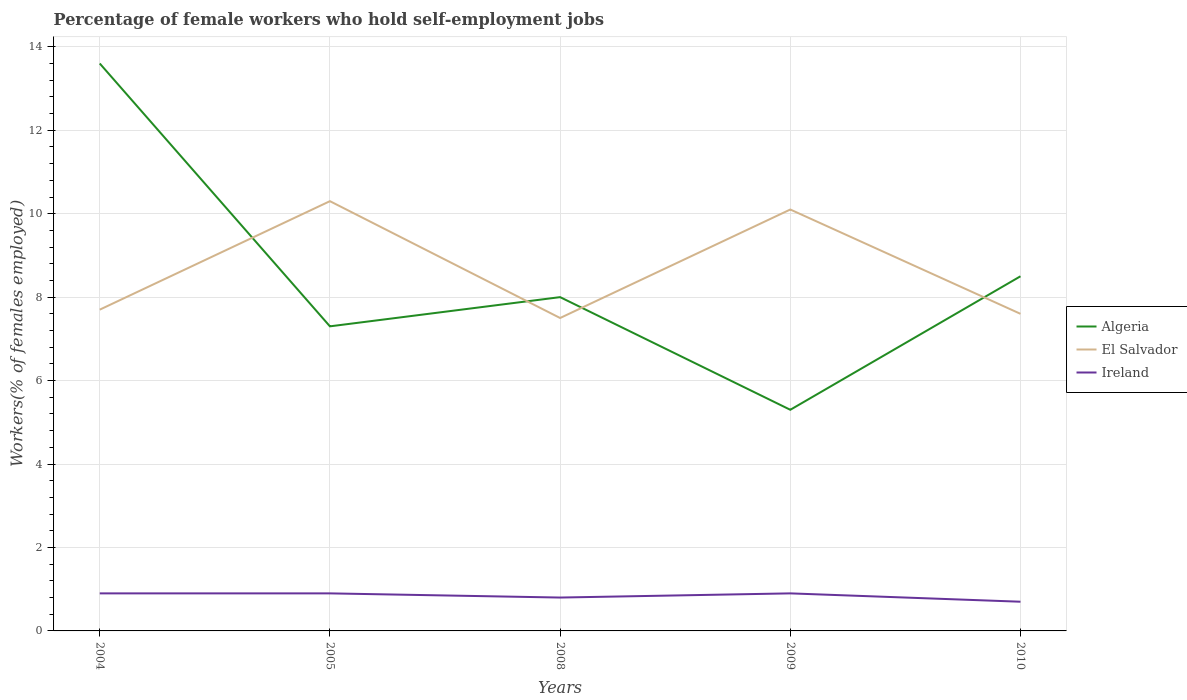Does the line corresponding to Ireland intersect with the line corresponding to Algeria?
Your answer should be very brief. No. Is the number of lines equal to the number of legend labels?
Give a very brief answer. Yes. Across all years, what is the maximum percentage of self-employed female workers in Ireland?
Offer a terse response. 0.7. In which year was the percentage of self-employed female workers in El Salvador maximum?
Offer a very short reply. 2008. What is the total percentage of self-employed female workers in Ireland in the graph?
Offer a terse response. 0.1. What is the difference between the highest and the second highest percentage of self-employed female workers in El Salvador?
Offer a very short reply. 2.8. Is the percentage of self-employed female workers in Ireland strictly greater than the percentage of self-employed female workers in El Salvador over the years?
Ensure brevity in your answer.  Yes. How many lines are there?
Make the answer very short. 3. Are the values on the major ticks of Y-axis written in scientific E-notation?
Keep it short and to the point. No. Does the graph contain any zero values?
Your response must be concise. No. Does the graph contain grids?
Your response must be concise. Yes. What is the title of the graph?
Ensure brevity in your answer.  Percentage of female workers who hold self-employment jobs. What is the label or title of the Y-axis?
Your answer should be compact. Workers(% of females employed). What is the Workers(% of females employed) in Algeria in 2004?
Give a very brief answer. 13.6. What is the Workers(% of females employed) in El Salvador in 2004?
Give a very brief answer. 7.7. What is the Workers(% of females employed) of Ireland in 2004?
Your answer should be compact. 0.9. What is the Workers(% of females employed) of Algeria in 2005?
Your response must be concise. 7.3. What is the Workers(% of females employed) in El Salvador in 2005?
Keep it short and to the point. 10.3. What is the Workers(% of females employed) of Ireland in 2005?
Provide a short and direct response. 0.9. What is the Workers(% of females employed) in Algeria in 2008?
Ensure brevity in your answer.  8. What is the Workers(% of females employed) in El Salvador in 2008?
Your response must be concise. 7.5. What is the Workers(% of females employed) of Ireland in 2008?
Provide a short and direct response. 0.8. What is the Workers(% of females employed) in Algeria in 2009?
Provide a short and direct response. 5.3. What is the Workers(% of females employed) in El Salvador in 2009?
Offer a terse response. 10.1. What is the Workers(% of females employed) in Ireland in 2009?
Your answer should be compact. 0.9. What is the Workers(% of females employed) of El Salvador in 2010?
Ensure brevity in your answer.  7.6. What is the Workers(% of females employed) of Ireland in 2010?
Provide a short and direct response. 0.7. Across all years, what is the maximum Workers(% of females employed) of Algeria?
Give a very brief answer. 13.6. Across all years, what is the maximum Workers(% of females employed) in El Salvador?
Provide a short and direct response. 10.3. Across all years, what is the maximum Workers(% of females employed) of Ireland?
Make the answer very short. 0.9. Across all years, what is the minimum Workers(% of females employed) in Algeria?
Give a very brief answer. 5.3. Across all years, what is the minimum Workers(% of females employed) of Ireland?
Give a very brief answer. 0.7. What is the total Workers(% of females employed) of Algeria in the graph?
Your answer should be compact. 42.7. What is the total Workers(% of females employed) in El Salvador in the graph?
Make the answer very short. 43.2. What is the difference between the Workers(% of females employed) of Algeria in 2004 and that in 2005?
Your response must be concise. 6.3. What is the difference between the Workers(% of females employed) of Ireland in 2004 and that in 2005?
Provide a succinct answer. 0. What is the difference between the Workers(% of females employed) of El Salvador in 2004 and that in 2008?
Your answer should be compact. 0.2. What is the difference between the Workers(% of females employed) in Ireland in 2004 and that in 2008?
Make the answer very short. 0.1. What is the difference between the Workers(% of females employed) in El Salvador in 2004 and that in 2009?
Give a very brief answer. -2.4. What is the difference between the Workers(% of females employed) of Algeria in 2004 and that in 2010?
Ensure brevity in your answer.  5.1. What is the difference between the Workers(% of females employed) of El Salvador in 2005 and that in 2008?
Provide a succinct answer. 2.8. What is the difference between the Workers(% of females employed) of Ireland in 2005 and that in 2008?
Your answer should be very brief. 0.1. What is the difference between the Workers(% of females employed) of El Salvador in 2005 and that in 2009?
Ensure brevity in your answer.  0.2. What is the difference between the Workers(% of females employed) in Algeria in 2005 and that in 2010?
Your response must be concise. -1.2. What is the difference between the Workers(% of females employed) of El Salvador in 2005 and that in 2010?
Offer a very short reply. 2.7. What is the difference between the Workers(% of females employed) of Ireland in 2005 and that in 2010?
Make the answer very short. 0.2. What is the difference between the Workers(% of females employed) in Algeria in 2008 and that in 2009?
Ensure brevity in your answer.  2.7. What is the difference between the Workers(% of females employed) of El Salvador in 2008 and that in 2009?
Provide a succinct answer. -2.6. What is the difference between the Workers(% of females employed) in Algeria in 2009 and that in 2010?
Offer a very short reply. -3.2. What is the difference between the Workers(% of females employed) of Ireland in 2009 and that in 2010?
Provide a succinct answer. 0.2. What is the difference between the Workers(% of females employed) in Algeria in 2004 and the Workers(% of females employed) in Ireland in 2005?
Your answer should be compact. 12.7. What is the difference between the Workers(% of females employed) of Algeria in 2004 and the Workers(% of females employed) of El Salvador in 2008?
Provide a succinct answer. 6.1. What is the difference between the Workers(% of females employed) of El Salvador in 2004 and the Workers(% of females employed) of Ireland in 2008?
Provide a short and direct response. 6.9. What is the difference between the Workers(% of females employed) of Algeria in 2004 and the Workers(% of females employed) of El Salvador in 2009?
Provide a succinct answer. 3.5. What is the difference between the Workers(% of females employed) of Algeria in 2004 and the Workers(% of females employed) of Ireland in 2009?
Offer a very short reply. 12.7. What is the difference between the Workers(% of females employed) in Algeria in 2004 and the Workers(% of females employed) in El Salvador in 2010?
Give a very brief answer. 6. What is the difference between the Workers(% of females employed) of El Salvador in 2004 and the Workers(% of females employed) of Ireland in 2010?
Your answer should be very brief. 7. What is the difference between the Workers(% of females employed) in Algeria in 2005 and the Workers(% of females employed) in El Salvador in 2009?
Give a very brief answer. -2.8. What is the difference between the Workers(% of females employed) in El Salvador in 2005 and the Workers(% of females employed) in Ireland in 2009?
Your response must be concise. 9.4. What is the difference between the Workers(% of females employed) in El Salvador in 2005 and the Workers(% of females employed) in Ireland in 2010?
Give a very brief answer. 9.6. What is the difference between the Workers(% of females employed) of Algeria in 2008 and the Workers(% of females employed) of El Salvador in 2009?
Keep it short and to the point. -2.1. What is the difference between the Workers(% of females employed) in Algeria in 2008 and the Workers(% of females employed) in Ireland in 2009?
Keep it short and to the point. 7.1. What is the difference between the Workers(% of females employed) of El Salvador in 2008 and the Workers(% of females employed) of Ireland in 2009?
Offer a very short reply. 6.6. What is the difference between the Workers(% of females employed) of Algeria in 2008 and the Workers(% of females employed) of El Salvador in 2010?
Ensure brevity in your answer.  0.4. What is the difference between the Workers(% of females employed) of Algeria in 2008 and the Workers(% of females employed) of Ireland in 2010?
Provide a short and direct response. 7.3. What is the average Workers(% of females employed) of Algeria per year?
Offer a very short reply. 8.54. What is the average Workers(% of females employed) of El Salvador per year?
Keep it short and to the point. 8.64. What is the average Workers(% of females employed) in Ireland per year?
Make the answer very short. 0.84. In the year 2004, what is the difference between the Workers(% of females employed) of Algeria and Workers(% of females employed) of Ireland?
Your answer should be compact. 12.7. In the year 2005, what is the difference between the Workers(% of females employed) in Algeria and Workers(% of females employed) in El Salvador?
Give a very brief answer. -3. In the year 2005, what is the difference between the Workers(% of females employed) in Algeria and Workers(% of females employed) in Ireland?
Your answer should be compact. 6.4. In the year 2005, what is the difference between the Workers(% of females employed) of El Salvador and Workers(% of females employed) of Ireland?
Give a very brief answer. 9.4. In the year 2008, what is the difference between the Workers(% of females employed) of Algeria and Workers(% of females employed) of El Salvador?
Offer a terse response. 0.5. In the year 2008, what is the difference between the Workers(% of females employed) of El Salvador and Workers(% of females employed) of Ireland?
Your answer should be very brief. 6.7. In the year 2009, what is the difference between the Workers(% of females employed) in Algeria and Workers(% of females employed) in El Salvador?
Your response must be concise. -4.8. In the year 2009, what is the difference between the Workers(% of females employed) of El Salvador and Workers(% of females employed) of Ireland?
Provide a short and direct response. 9.2. In the year 2010, what is the difference between the Workers(% of females employed) of Algeria and Workers(% of females employed) of El Salvador?
Your answer should be compact. 0.9. What is the ratio of the Workers(% of females employed) of Algeria in 2004 to that in 2005?
Your answer should be very brief. 1.86. What is the ratio of the Workers(% of females employed) in El Salvador in 2004 to that in 2005?
Ensure brevity in your answer.  0.75. What is the ratio of the Workers(% of females employed) in Algeria in 2004 to that in 2008?
Give a very brief answer. 1.7. What is the ratio of the Workers(% of females employed) of El Salvador in 2004 to that in 2008?
Your answer should be very brief. 1.03. What is the ratio of the Workers(% of females employed) of Algeria in 2004 to that in 2009?
Give a very brief answer. 2.57. What is the ratio of the Workers(% of females employed) in El Salvador in 2004 to that in 2009?
Provide a short and direct response. 0.76. What is the ratio of the Workers(% of females employed) of Algeria in 2004 to that in 2010?
Provide a succinct answer. 1.6. What is the ratio of the Workers(% of females employed) in El Salvador in 2004 to that in 2010?
Provide a succinct answer. 1.01. What is the ratio of the Workers(% of females employed) of Ireland in 2004 to that in 2010?
Keep it short and to the point. 1.29. What is the ratio of the Workers(% of females employed) of Algeria in 2005 to that in 2008?
Your answer should be compact. 0.91. What is the ratio of the Workers(% of females employed) of El Salvador in 2005 to that in 2008?
Your response must be concise. 1.37. What is the ratio of the Workers(% of females employed) of Ireland in 2005 to that in 2008?
Ensure brevity in your answer.  1.12. What is the ratio of the Workers(% of females employed) in Algeria in 2005 to that in 2009?
Provide a short and direct response. 1.38. What is the ratio of the Workers(% of females employed) of El Salvador in 2005 to that in 2009?
Make the answer very short. 1.02. What is the ratio of the Workers(% of females employed) in Algeria in 2005 to that in 2010?
Ensure brevity in your answer.  0.86. What is the ratio of the Workers(% of females employed) in El Salvador in 2005 to that in 2010?
Provide a short and direct response. 1.36. What is the ratio of the Workers(% of females employed) in Ireland in 2005 to that in 2010?
Ensure brevity in your answer.  1.29. What is the ratio of the Workers(% of females employed) in Algeria in 2008 to that in 2009?
Make the answer very short. 1.51. What is the ratio of the Workers(% of females employed) in El Salvador in 2008 to that in 2009?
Keep it short and to the point. 0.74. What is the ratio of the Workers(% of females employed) of Algeria in 2008 to that in 2010?
Provide a succinct answer. 0.94. What is the ratio of the Workers(% of females employed) of El Salvador in 2008 to that in 2010?
Offer a terse response. 0.99. What is the ratio of the Workers(% of females employed) in Algeria in 2009 to that in 2010?
Ensure brevity in your answer.  0.62. What is the ratio of the Workers(% of females employed) in El Salvador in 2009 to that in 2010?
Your answer should be very brief. 1.33. What is the difference between the highest and the second highest Workers(% of females employed) of Algeria?
Your answer should be very brief. 5.1. What is the difference between the highest and the second highest Workers(% of females employed) in Ireland?
Your response must be concise. 0. What is the difference between the highest and the lowest Workers(% of females employed) in El Salvador?
Your answer should be compact. 2.8. 